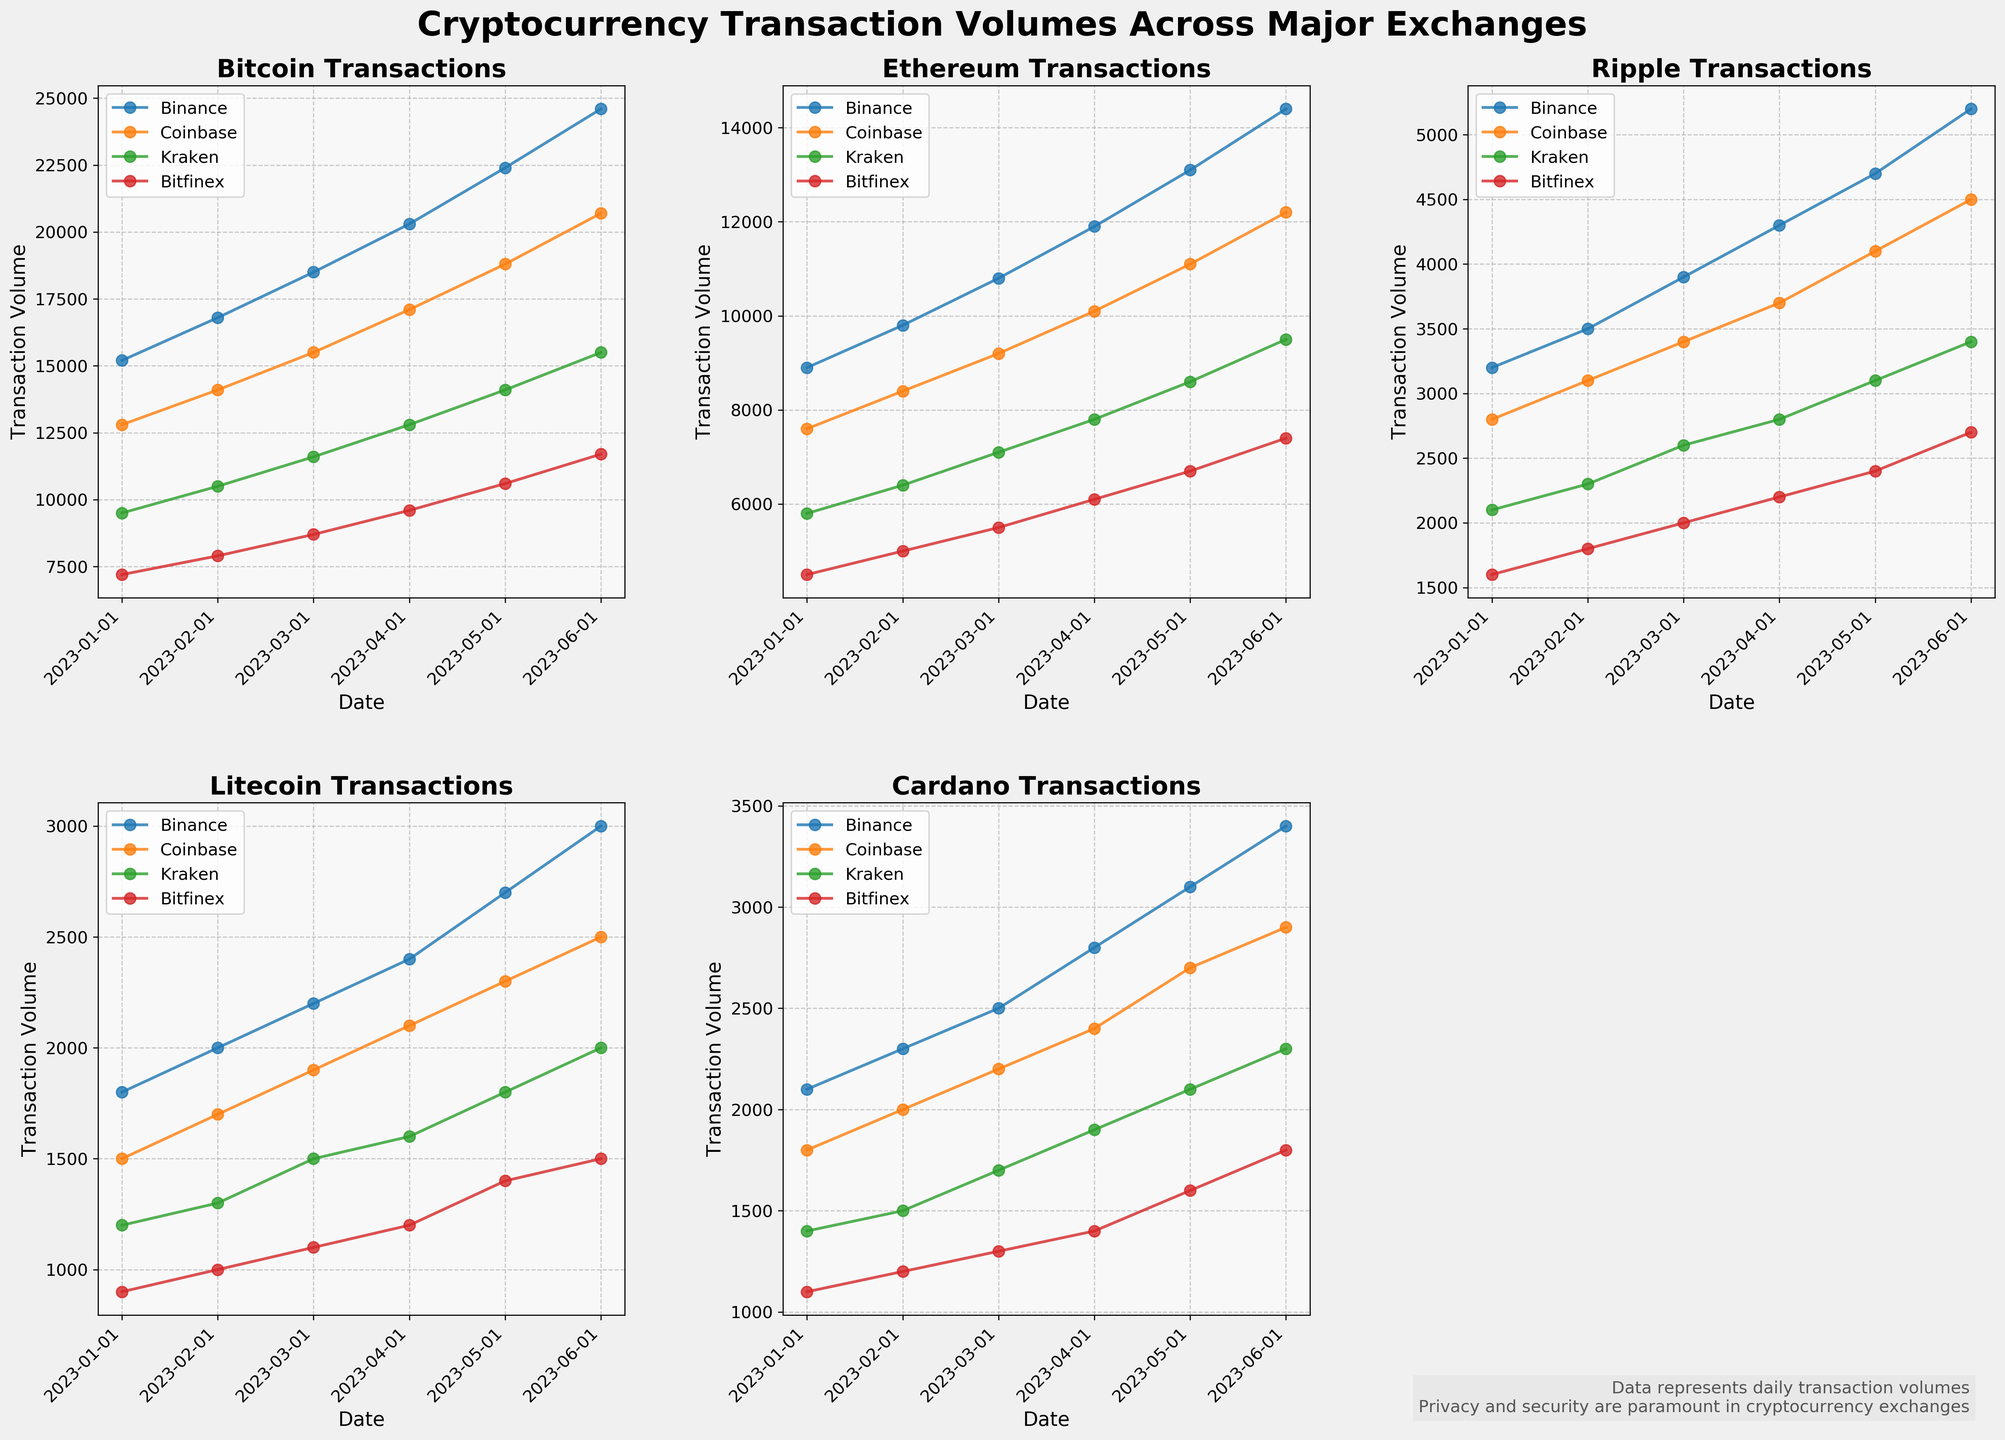Which exchange had the highest Bitcoin transaction volume on the most recent date? Look at the subplot for Bitcoin transactions and compare the heights of the lines for the different exchanges on the latest date (June 1, 2023). Binance has the highest line.
Answer: Binance Between Kraken and Coinbase, which exchange saw a greater increase in Ethereum transaction volume from January to June 2023? Look at the Ethereum subplot and compare the position of Kraken and Coinbase lines on January and June 2023. Kraken increased from 5800 to 9500, a growth of 3700, while Coinbase increased from 7600 to 12200, a growth of 4600.
Answer: Coinbase Summing up the transaction volumes of Litecoin for all exchanges on April 1, 2023, what is the total? Find the values for Litecoin transactions on April 1, 2023, from each exchange: Binance (2400), Coinbase (2100), Kraken (1600), and Bitfinex (1200). Summing these gives 2400 + 2100 + 1600 + 1200.
Answer: 7300 Which blockchain shows the highest overall transaction volume across all exchanges in June 2023? Compare the subplot lines on June 2023. Bitcoin has the highest lines for all exchanges compared to other blockchains.
Answer: Bitcoin How does Binances's transaction volume of Ripple in March 2023 compare to Bitfinex's transaction volume of Cardano in the same period? Locate Binance's Ripple transaction volume (3900) and Bitfinex's Cardano transaction volume (1300) in their respective subplots for March 2023. Ripple is higher on Binance.
Answer: Binance's Ripple is higher Which cryptocurrency showed a consistent increase in transaction volume across all exchanges from January to June 2023? Check each cryptocurrency subplot to see if all exchanges show an increasing trend line from January to June 2023. Bitcoin's lines consistently increase across all exchanges.
Answer: Bitcoin Calculate the percentage increase of Cardano's transaction volume on Kraken from March to June 2023. Check Kraken's Cardano transaction volumes in March (1700) and June (2300). The percentage increase is ((2300 - 1700) / 1700) * 100.
Answer: 35.3% In what month did Bitfinex see the highest XRP transaction volume and what was its value? Look for the peak of Bitfinex's line in the Ripple subplot. The highest point is in June 2023, with a value of 2700.
Answer: June 2023; 2700 During which month did Ethereum transactions on Coinbase surpass Bitcoin transactions for the first time? Compare the lines for Ethereum and Bitcoin on Coinbase subplot month-by-month. In no month does Ethereum surpass Bitcoin transactions.
Answer: Never Which exchange experienced the largest increase in transaction volume for Litecoin from January to February 2023, and what was the size of the increase? Check Litecoin transaction volumes for January and February across all exchanges. Binance increased by 200 (2000 - 1800), while other exchanges increased less.
Answer: Binance; 200 